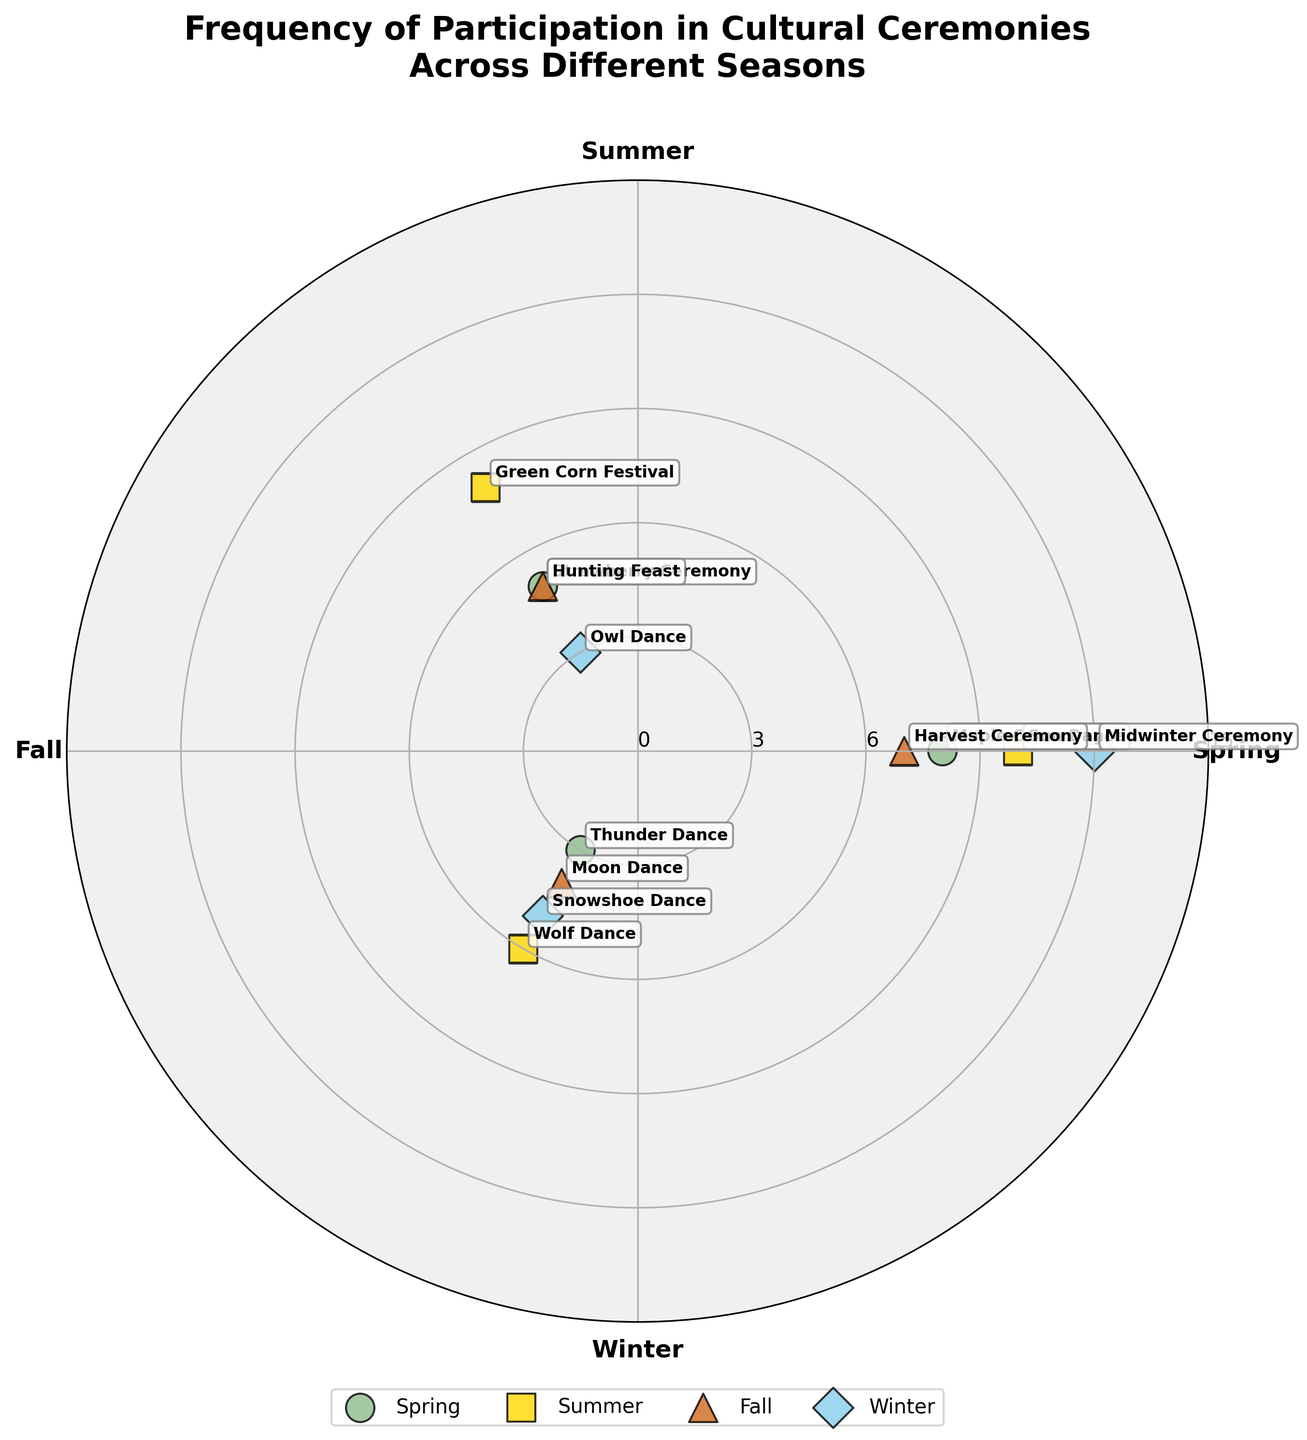What is the title of the figure? The title is usually the text at the top of the figure that summarizes the content or purpose of the chart.
Answer: "Frequency of Participation in Cultural Ceremonies Across Different Seasons" Which season has the highest number of participation for a single ceremony? By looking at each season's section in the polar chart, the longest point from the center indicates the highest value. The "Midwinter Ceremony" in Winter is the highest at 12 frequencies.
Answer: Winter What are the total frequencies of participation in Summer ceremonies? Sum the frequencies of all ceremonies in Summer: Sun Dance (10) + Green Corn Festival (8) + Wolf Dance (6). 10 + 8 + 6 = 24.
Answer: 24 Which ceremony has the lowest frequency of participation? Identify the smallest data point on the polar scatter chart. The "Thunder Dance" in Spring and "Owl Dance" in Winter both have a frequency of 3, which is the lowest.
Answer: Thunder Dance and Owl Dance How does the participation frequency of the Harvest Ceremony compare to the Moon Dance? Identify the data points for "Harvest Ceremony" and "Moon Dance" and compare their distances from the center. "Harvest Ceremony" in Fall has a frequency of 7, while "Moon Dance" has a frequency of 4. Therefore, the Harvest Ceremony has a higher participation frequency.
Answer: Higher Which season has the lowest average frequency of participation across its ceremonies? Calculate the average frequencies for all seasons. Spring: (8+5+3)/3 = 16/3 ≈ 5.33. Summer: (10+8+6)/3 = 24/3 = 8. Fall: (7+5+4)/3 = 16/3 ≈ 5.33. Winter: (12+3+5)/3 = 20/3 ≈ 6.67. Both Spring and Fall have the lowest average at approximately 5.33.
Answer: Spring and Fall What are the ceremonies with even-numbered frequencies? Identify ceremonies with frequencies that are even numbers. They are "Maple Ceremony" (8), "Sun Dance" (10), "Green Corn Festival" (8), "Snowshoe Dance" (5), and "Harvest Ceremony" (7).
Answer: Maple Ceremony, Sun Dance, Green Corn Festival, Snowshoe Dance, and Harvest Ceremony Which season's ceremonies have the most diverse range of frequencies? Determine the range (difference between the highest and lowest frequencies) for each season. Spring: 8 - 3 = 5, Summer: 10 - 6 = 4, Fall: 7 - 4 = 3, Winter: 12 - 3 = 9. Winter has the widest range of 9.
Answer: Winter What is the median frequency of participation across all ceremonies? List all frequencies: [8, 5, 3, 10, 8, 6, 7, 5, 4, 12, 3, 5], and then sort them: [3, 3, 4, 5, 5, 5, 6, 7, 8, 8, 10, 12]. The median value (middle value) for an even number of observations is the average of the 6th and 7th values: (5+6)/2 = 5.5.
Answer: 5.5 